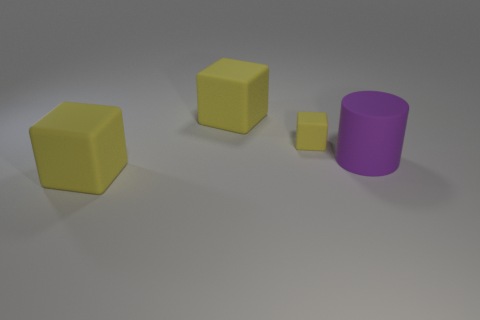Subtract all small yellow cubes. How many cubes are left? 2 Subtract all cylinders. How many objects are left? 3 Add 1 gray things. How many objects exist? 5 Subtract 1 cylinders. How many cylinders are left? 0 Subtract all cyan blocks. Subtract all brown cylinders. How many blocks are left? 3 Subtract all small matte cubes. Subtract all tiny things. How many objects are left? 2 Add 2 purple cylinders. How many purple cylinders are left? 3 Add 2 purple cylinders. How many purple cylinders exist? 3 Subtract 0 red spheres. How many objects are left? 4 